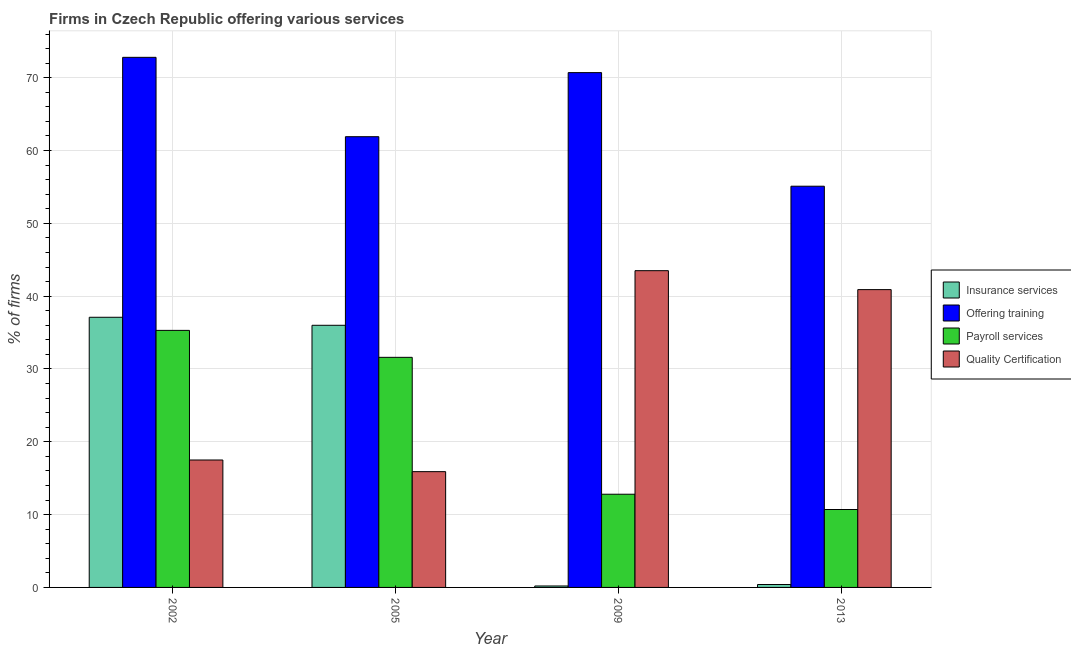How many different coloured bars are there?
Offer a very short reply. 4. How many groups of bars are there?
Offer a very short reply. 4. How many bars are there on the 1st tick from the left?
Make the answer very short. 4. What is the percentage of firms offering payroll services in 2005?
Provide a succinct answer. 31.6. Across all years, what is the maximum percentage of firms offering training?
Your answer should be very brief. 72.8. What is the total percentage of firms offering insurance services in the graph?
Provide a short and direct response. 73.7. What is the difference between the percentage of firms offering insurance services in 2005 and that in 2009?
Offer a very short reply. 35.8. What is the difference between the percentage of firms offering insurance services in 2013 and the percentage of firms offering quality certification in 2002?
Keep it short and to the point. -36.7. What is the average percentage of firms offering insurance services per year?
Ensure brevity in your answer.  18.43. In how many years, is the percentage of firms offering payroll services greater than 32 %?
Provide a short and direct response. 1. What is the ratio of the percentage of firms offering payroll services in 2002 to that in 2013?
Your answer should be compact. 3.3. What is the difference between the highest and the second highest percentage of firms offering training?
Your answer should be very brief. 2.1. What is the difference between the highest and the lowest percentage of firms offering training?
Your answer should be compact. 17.7. In how many years, is the percentage of firms offering training greater than the average percentage of firms offering training taken over all years?
Ensure brevity in your answer.  2. What does the 1st bar from the left in 2009 represents?
Give a very brief answer. Insurance services. What does the 3rd bar from the right in 2013 represents?
Keep it short and to the point. Offering training. Are all the bars in the graph horizontal?
Make the answer very short. No. What is the difference between two consecutive major ticks on the Y-axis?
Offer a very short reply. 10. Are the values on the major ticks of Y-axis written in scientific E-notation?
Give a very brief answer. No. Does the graph contain any zero values?
Provide a succinct answer. No. Where does the legend appear in the graph?
Offer a very short reply. Center right. How are the legend labels stacked?
Your answer should be compact. Vertical. What is the title of the graph?
Make the answer very short. Firms in Czech Republic offering various services . What is the label or title of the X-axis?
Offer a terse response. Year. What is the label or title of the Y-axis?
Your response must be concise. % of firms. What is the % of firms in Insurance services in 2002?
Ensure brevity in your answer.  37.1. What is the % of firms of Offering training in 2002?
Provide a succinct answer. 72.8. What is the % of firms of Payroll services in 2002?
Offer a very short reply. 35.3. What is the % of firms of Offering training in 2005?
Offer a terse response. 61.9. What is the % of firms of Payroll services in 2005?
Keep it short and to the point. 31.6. What is the % of firms in Quality Certification in 2005?
Offer a very short reply. 15.9. What is the % of firms in Insurance services in 2009?
Keep it short and to the point. 0.2. What is the % of firms of Offering training in 2009?
Ensure brevity in your answer.  70.7. What is the % of firms of Quality Certification in 2009?
Make the answer very short. 43.5. What is the % of firms of Offering training in 2013?
Your answer should be very brief. 55.1. What is the % of firms in Quality Certification in 2013?
Make the answer very short. 40.9. Across all years, what is the maximum % of firms in Insurance services?
Offer a terse response. 37.1. Across all years, what is the maximum % of firms in Offering training?
Offer a very short reply. 72.8. Across all years, what is the maximum % of firms of Payroll services?
Make the answer very short. 35.3. Across all years, what is the maximum % of firms in Quality Certification?
Offer a very short reply. 43.5. Across all years, what is the minimum % of firms in Offering training?
Provide a short and direct response. 55.1. Across all years, what is the minimum % of firms of Payroll services?
Your answer should be compact. 10.7. What is the total % of firms in Insurance services in the graph?
Provide a succinct answer. 73.7. What is the total % of firms of Offering training in the graph?
Your answer should be compact. 260.5. What is the total % of firms of Payroll services in the graph?
Your response must be concise. 90.4. What is the total % of firms in Quality Certification in the graph?
Give a very brief answer. 117.8. What is the difference between the % of firms of Insurance services in 2002 and that in 2005?
Offer a terse response. 1.1. What is the difference between the % of firms of Payroll services in 2002 and that in 2005?
Offer a very short reply. 3.7. What is the difference between the % of firms of Quality Certification in 2002 and that in 2005?
Provide a succinct answer. 1.6. What is the difference between the % of firms in Insurance services in 2002 and that in 2009?
Keep it short and to the point. 36.9. What is the difference between the % of firms in Offering training in 2002 and that in 2009?
Your answer should be very brief. 2.1. What is the difference between the % of firms of Payroll services in 2002 and that in 2009?
Ensure brevity in your answer.  22.5. What is the difference between the % of firms of Quality Certification in 2002 and that in 2009?
Keep it short and to the point. -26. What is the difference between the % of firms of Insurance services in 2002 and that in 2013?
Your answer should be compact. 36.7. What is the difference between the % of firms in Payroll services in 2002 and that in 2013?
Provide a short and direct response. 24.6. What is the difference between the % of firms in Quality Certification in 2002 and that in 2013?
Provide a succinct answer. -23.4. What is the difference between the % of firms of Insurance services in 2005 and that in 2009?
Offer a terse response. 35.8. What is the difference between the % of firms in Quality Certification in 2005 and that in 2009?
Your answer should be very brief. -27.6. What is the difference between the % of firms of Insurance services in 2005 and that in 2013?
Provide a succinct answer. 35.6. What is the difference between the % of firms of Offering training in 2005 and that in 2013?
Offer a very short reply. 6.8. What is the difference between the % of firms of Payroll services in 2005 and that in 2013?
Your answer should be compact. 20.9. What is the difference between the % of firms of Insurance services in 2009 and that in 2013?
Provide a succinct answer. -0.2. What is the difference between the % of firms in Payroll services in 2009 and that in 2013?
Make the answer very short. 2.1. What is the difference between the % of firms in Quality Certification in 2009 and that in 2013?
Offer a terse response. 2.6. What is the difference between the % of firms in Insurance services in 2002 and the % of firms in Offering training in 2005?
Make the answer very short. -24.8. What is the difference between the % of firms in Insurance services in 2002 and the % of firms in Quality Certification in 2005?
Ensure brevity in your answer.  21.2. What is the difference between the % of firms in Offering training in 2002 and the % of firms in Payroll services in 2005?
Provide a succinct answer. 41.2. What is the difference between the % of firms of Offering training in 2002 and the % of firms of Quality Certification in 2005?
Give a very brief answer. 56.9. What is the difference between the % of firms in Payroll services in 2002 and the % of firms in Quality Certification in 2005?
Provide a succinct answer. 19.4. What is the difference between the % of firms in Insurance services in 2002 and the % of firms in Offering training in 2009?
Give a very brief answer. -33.6. What is the difference between the % of firms of Insurance services in 2002 and the % of firms of Payroll services in 2009?
Make the answer very short. 24.3. What is the difference between the % of firms of Offering training in 2002 and the % of firms of Quality Certification in 2009?
Provide a succinct answer. 29.3. What is the difference between the % of firms of Insurance services in 2002 and the % of firms of Payroll services in 2013?
Offer a very short reply. 26.4. What is the difference between the % of firms of Offering training in 2002 and the % of firms of Payroll services in 2013?
Your response must be concise. 62.1. What is the difference between the % of firms of Offering training in 2002 and the % of firms of Quality Certification in 2013?
Give a very brief answer. 31.9. What is the difference between the % of firms of Payroll services in 2002 and the % of firms of Quality Certification in 2013?
Your answer should be very brief. -5.6. What is the difference between the % of firms in Insurance services in 2005 and the % of firms in Offering training in 2009?
Offer a very short reply. -34.7. What is the difference between the % of firms in Insurance services in 2005 and the % of firms in Payroll services in 2009?
Your answer should be very brief. 23.2. What is the difference between the % of firms in Offering training in 2005 and the % of firms in Payroll services in 2009?
Your answer should be compact. 49.1. What is the difference between the % of firms in Insurance services in 2005 and the % of firms in Offering training in 2013?
Your response must be concise. -19.1. What is the difference between the % of firms in Insurance services in 2005 and the % of firms in Payroll services in 2013?
Provide a short and direct response. 25.3. What is the difference between the % of firms in Insurance services in 2005 and the % of firms in Quality Certification in 2013?
Your answer should be compact. -4.9. What is the difference between the % of firms in Offering training in 2005 and the % of firms in Payroll services in 2013?
Offer a terse response. 51.2. What is the difference between the % of firms of Payroll services in 2005 and the % of firms of Quality Certification in 2013?
Your answer should be very brief. -9.3. What is the difference between the % of firms of Insurance services in 2009 and the % of firms of Offering training in 2013?
Provide a succinct answer. -54.9. What is the difference between the % of firms of Insurance services in 2009 and the % of firms of Payroll services in 2013?
Ensure brevity in your answer.  -10.5. What is the difference between the % of firms of Insurance services in 2009 and the % of firms of Quality Certification in 2013?
Provide a succinct answer. -40.7. What is the difference between the % of firms in Offering training in 2009 and the % of firms in Payroll services in 2013?
Make the answer very short. 60. What is the difference between the % of firms in Offering training in 2009 and the % of firms in Quality Certification in 2013?
Make the answer very short. 29.8. What is the difference between the % of firms in Payroll services in 2009 and the % of firms in Quality Certification in 2013?
Provide a succinct answer. -28.1. What is the average % of firms in Insurance services per year?
Provide a succinct answer. 18.43. What is the average % of firms of Offering training per year?
Ensure brevity in your answer.  65.12. What is the average % of firms in Payroll services per year?
Give a very brief answer. 22.6. What is the average % of firms of Quality Certification per year?
Your answer should be very brief. 29.45. In the year 2002, what is the difference between the % of firms in Insurance services and % of firms in Offering training?
Offer a terse response. -35.7. In the year 2002, what is the difference between the % of firms of Insurance services and % of firms of Quality Certification?
Your answer should be compact. 19.6. In the year 2002, what is the difference between the % of firms of Offering training and % of firms of Payroll services?
Make the answer very short. 37.5. In the year 2002, what is the difference between the % of firms in Offering training and % of firms in Quality Certification?
Your answer should be compact. 55.3. In the year 2005, what is the difference between the % of firms in Insurance services and % of firms in Offering training?
Your answer should be very brief. -25.9. In the year 2005, what is the difference between the % of firms of Insurance services and % of firms of Quality Certification?
Provide a short and direct response. 20.1. In the year 2005, what is the difference between the % of firms of Offering training and % of firms of Payroll services?
Keep it short and to the point. 30.3. In the year 2005, what is the difference between the % of firms in Payroll services and % of firms in Quality Certification?
Provide a short and direct response. 15.7. In the year 2009, what is the difference between the % of firms of Insurance services and % of firms of Offering training?
Your answer should be compact. -70.5. In the year 2009, what is the difference between the % of firms in Insurance services and % of firms in Payroll services?
Your answer should be very brief. -12.6. In the year 2009, what is the difference between the % of firms in Insurance services and % of firms in Quality Certification?
Your answer should be compact. -43.3. In the year 2009, what is the difference between the % of firms of Offering training and % of firms of Payroll services?
Make the answer very short. 57.9. In the year 2009, what is the difference between the % of firms in Offering training and % of firms in Quality Certification?
Your answer should be compact. 27.2. In the year 2009, what is the difference between the % of firms of Payroll services and % of firms of Quality Certification?
Keep it short and to the point. -30.7. In the year 2013, what is the difference between the % of firms of Insurance services and % of firms of Offering training?
Offer a terse response. -54.7. In the year 2013, what is the difference between the % of firms of Insurance services and % of firms of Quality Certification?
Offer a very short reply. -40.5. In the year 2013, what is the difference between the % of firms in Offering training and % of firms in Payroll services?
Provide a short and direct response. 44.4. In the year 2013, what is the difference between the % of firms in Offering training and % of firms in Quality Certification?
Your response must be concise. 14.2. In the year 2013, what is the difference between the % of firms of Payroll services and % of firms of Quality Certification?
Your answer should be compact. -30.2. What is the ratio of the % of firms in Insurance services in 2002 to that in 2005?
Your answer should be very brief. 1.03. What is the ratio of the % of firms of Offering training in 2002 to that in 2005?
Ensure brevity in your answer.  1.18. What is the ratio of the % of firms in Payroll services in 2002 to that in 2005?
Make the answer very short. 1.12. What is the ratio of the % of firms in Quality Certification in 2002 to that in 2005?
Keep it short and to the point. 1.1. What is the ratio of the % of firms of Insurance services in 2002 to that in 2009?
Your answer should be compact. 185.5. What is the ratio of the % of firms of Offering training in 2002 to that in 2009?
Give a very brief answer. 1.03. What is the ratio of the % of firms of Payroll services in 2002 to that in 2009?
Your answer should be very brief. 2.76. What is the ratio of the % of firms in Quality Certification in 2002 to that in 2009?
Provide a short and direct response. 0.4. What is the ratio of the % of firms in Insurance services in 2002 to that in 2013?
Offer a terse response. 92.75. What is the ratio of the % of firms of Offering training in 2002 to that in 2013?
Keep it short and to the point. 1.32. What is the ratio of the % of firms in Payroll services in 2002 to that in 2013?
Make the answer very short. 3.3. What is the ratio of the % of firms of Quality Certification in 2002 to that in 2013?
Your response must be concise. 0.43. What is the ratio of the % of firms in Insurance services in 2005 to that in 2009?
Provide a short and direct response. 180. What is the ratio of the % of firms of Offering training in 2005 to that in 2009?
Your response must be concise. 0.88. What is the ratio of the % of firms of Payroll services in 2005 to that in 2009?
Offer a terse response. 2.47. What is the ratio of the % of firms of Quality Certification in 2005 to that in 2009?
Your answer should be compact. 0.37. What is the ratio of the % of firms of Offering training in 2005 to that in 2013?
Ensure brevity in your answer.  1.12. What is the ratio of the % of firms in Payroll services in 2005 to that in 2013?
Ensure brevity in your answer.  2.95. What is the ratio of the % of firms of Quality Certification in 2005 to that in 2013?
Offer a terse response. 0.39. What is the ratio of the % of firms in Offering training in 2009 to that in 2013?
Your response must be concise. 1.28. What is the ratio of the % of firms of Payroll services in 2009 to that in 2013?
Provide a short and direct response. 1.2. What is the ratio of the % of firms in Quality Certification in 2009 to that in 2013?
Provide a short and direct response. 1.06. What is the difference between the highest and the second highest % of firms of Insurance services?
Your answer should be compact. 1.1. What is the difference between the highest and the second highest % of firms in Offering training?
Give a very brief answer. 2.1. What is the difference between the highest and the second highest % of firms in Payroll services?
Offer a terse response. 3.7. What is the difference between the highest and the lowest % of firms in Insurance services?
Give a very brief answer. 36.9. What is the difference between the highest and the lowest % of firms of Payroll services?
Offer a terse response. 24.6. What is the difference between the highest and the lowest % of firms in Quality Certification?
Ensure brevity in your answer.  27.6. 